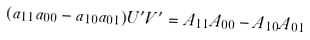Convert formula to latex. <formula><loc_0><loc_0><loc_500><loc_500>( a _ { 1 1 } a _ { 0 0 } - a _ { 1 0 } a _ { 0 1 } ) U ^ { \prime } V ^ { \prime } = A _ { 1 1 } A _ { 0 0 } - A _ { 1 0 } A _ { 0 1 }</formula> 